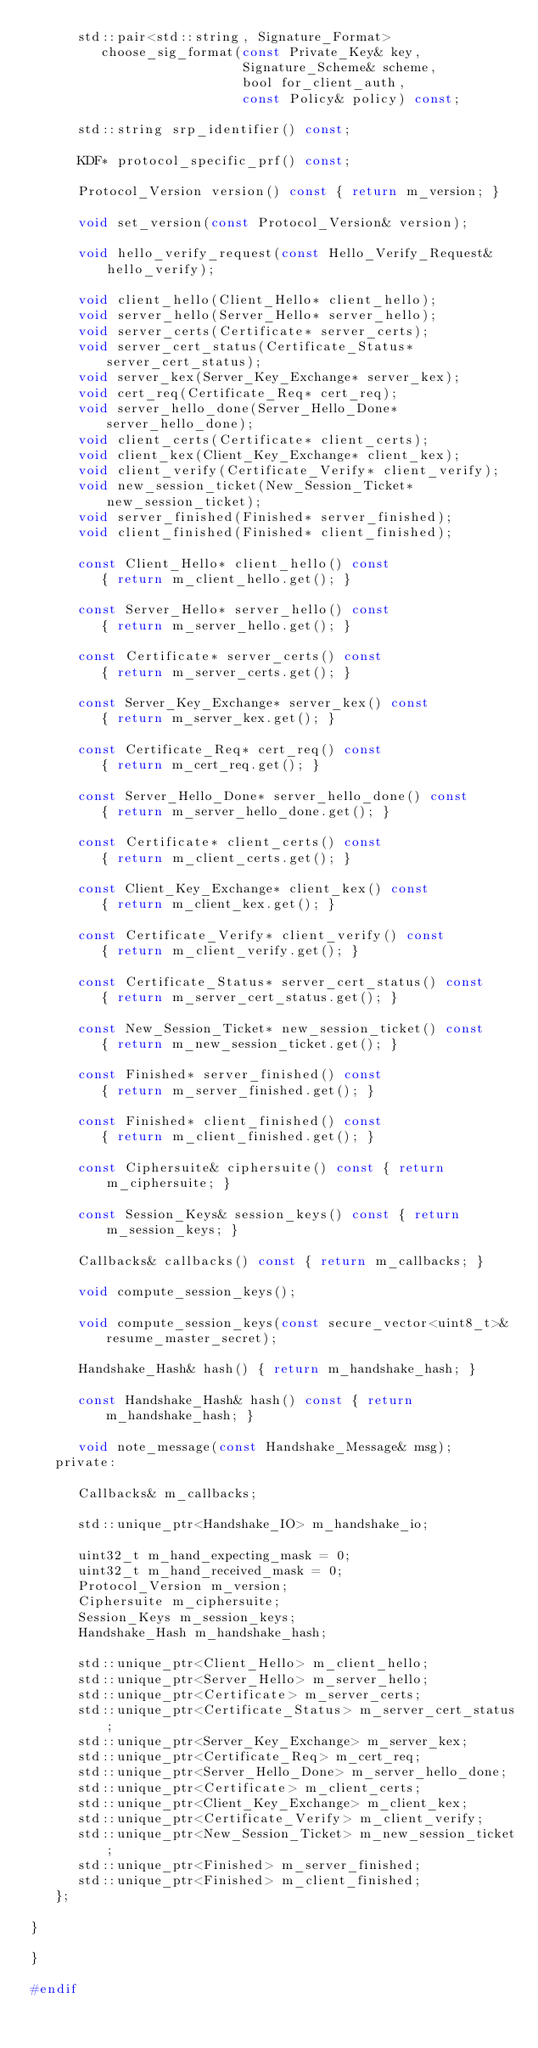<code> <loc_0><loc_0><loc_500><loc_500><_C_>      std::pair<std::string, Signature_Format>
         choose_sig_format(const Private_Key& key,
                           Signature_Scheme& scheme,
                           bool for_client_auth,
                           const Policy& policy) const;

      std::string srp_identifier() const;

      KDF* protocol_specific_prf() const;

      Protocol_Version version() const { return m_version; }

      void set_version(const Protocol_Version& version);

      void hello_verify_request(const Hello_Verify_Request& hello_verify);

      void client_hello(Client_Hello* client_hello);
      void server_hello(Server_Hello* server_hello);
      void server_certs(Certificate* server_certs);
      void server_cert_status(Certificate_Status* server_cert_status);
      void server_kex(Server_Key_Exchange* server_kex);
      void cert_req(Certificate_Req* cert_req);
      void server_hello_done(Server_Hello_Done* server_hello_done);
      void client_certs(Certificate* client_certs);
      void client_kex(Client_Key_Exchange* client_kex);
      void client_verify(Certificate_Verify* client_verify);
      void new_session_ticket(New_Session_Ticket* new_session_ticket);
      void server_finished(Finished* server_finished);
      void client_finished(Finished* client_finished);

      const Client_Hello* client_hello() const
         { return m_client_hello.get(); }

      const Server_Hello* server_hello() const
         { return m_server_hello.get(); }

      const Certificate* server_certs() const
         { return m_server_certs.get(); }

      const Server_Key_Exchange* server_kex() const
         { return m_server_kex.get(); }

      const Certificate_Req* cert_req() const
         { return m_cert_req.get(); }

      const Server_Hello_Done* server_hello_done() const
         { return m_server_hello_done.get(); }

      const Certificate* client_certs() const
         { return m_client_certs.get(); }

      const Client_Key_Exchange* client_kex() const
         { return m_client_kex.get(); }

      const Certificate_Verify* client_verify() const
         { return m_client_verify.get(); }

      const Certificate_Status* server_cert_status() const
         { return m_server_cert_status.get(); }

      const New_Session_Ticket* new_session_ticket() const
         { return m_new_session_ticket.get(); }

      const Finished* server_finished() const
         { return m_server_finished.get(); }

      const Finished* client_finished() const
         { return m_client_finished.get(); }

      const Ciphersuite& ciphersuite() const { return m_ciphersuite; }

      const Session_Keys& session_keys() const { return m_session_keys; }

      Callbacks& callbacks() const { return m_callbacks; }

      void compute_session_keys();

      void compute_session_keys(const secure_vector<uint8_t>& resume_master_secret);

      Handshake_Hash& hash() { return m_handshake_hash; }

      const Handshake_Hash& hash() const { return m_handshake_hash; }

      void note_message(const Handshake_Message& msg);
   private:

      Callbacks& m_callbacks;

      std::unique_ptr<Handshake_IO> m_handshake_io;

      uint32_t m_hand_expecting_mask = 0;
      uint32_t m_hand_received_mask = 0;
      Protocol_Version m_version;
      Ciphersuite m_ciphersuite;
      Session_Keys m_session_keys;
      Handshake_Hash m_handshake_hash;

      std::unique_ptr<Client_Hello> m_client_hello;
      std::unique_ptr<Server_Hello> m_server_hello;
      std::unique_ptr<Certificate> m_server_certs;
      std::unique_ptr<Certificate_Status> m_server_cert_status;
      std::unique_ptr<Server_Key_Exchange> m_server_kex;
      std::unique_ptr<Certificate_Req> m_cert_req;
      std::unique_ptr<Server_Hello_Done> m_server_hello_done;
      std::unique_ptr<Certificate> m_client_certs;
      std::unique_ptr<Client_Key_Exchange> m_client_kex;
      std::unique_ptr<Certificate_Verify> m_client_verify;
      std::unique_ptr<New_Session_Ticket> m_new_session_ticket;
      std::unique_ptr<Finished> m_server_finished;
      std::unique_ptr<Finished> m_client_finished;
   };

}

}

#endif
</code> 